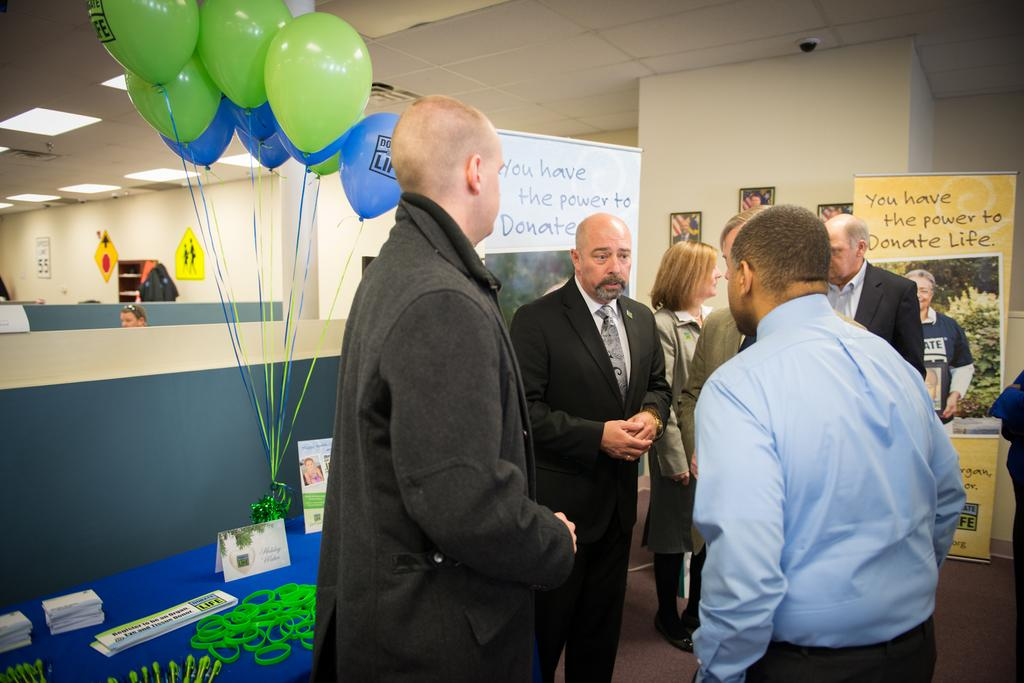How many people are in the image? There is a group of people standing in the image. What is the surface on which the people are standing? The people are standing on the floor. What decorations can be seen in the image? There are balloons, bands, banners, frames, posters, and lights in the image. What type of match is being played in the image? There is no match being played in the image; it features a group of people and various decorations. Is there an oven visible in the image? No, there is no oven present in the image. 